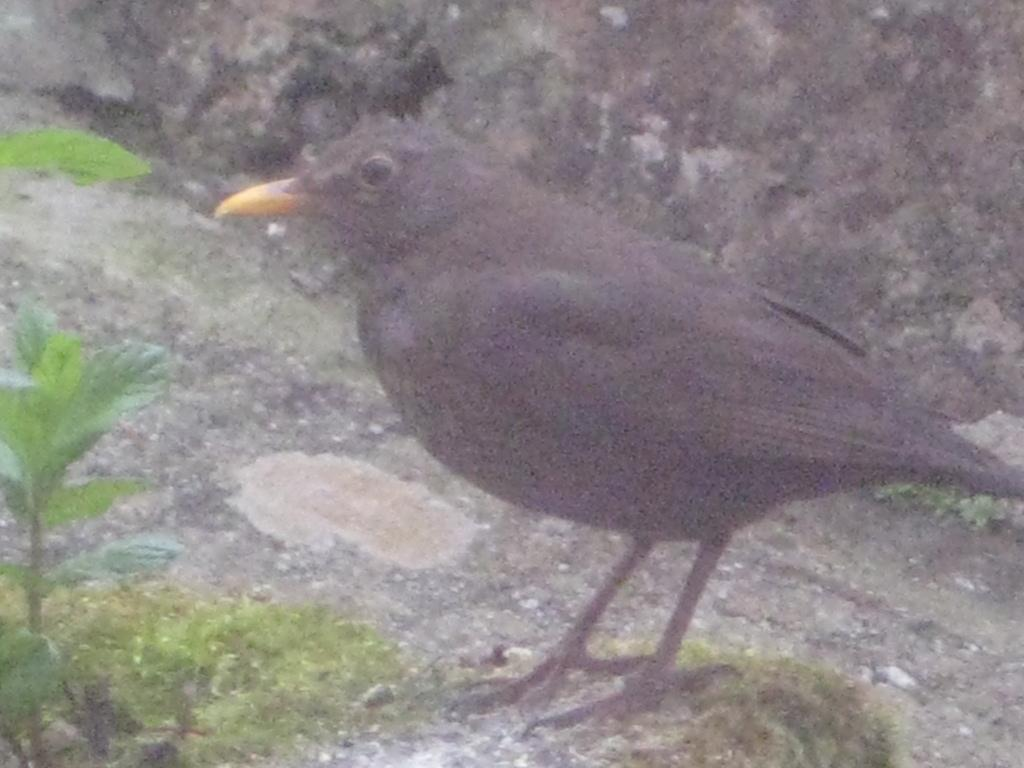What type of animal can be seen in the image? There is a bird in the image. Where is the bird located? The bird is sitting on the land. What can be seen on the left side of the image? There is a stem with leaves on the left side of the image. How does the bird make the visitor feel comfortable in the image? There is no visitor present in the image, so it is not possible to determine how the bird might affect their comfort. 